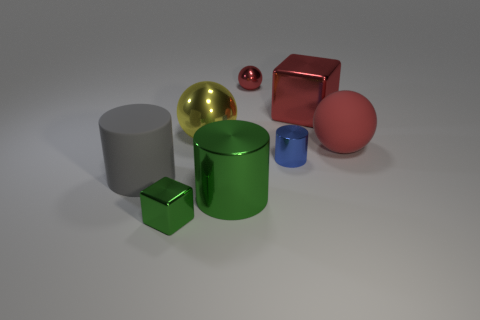There is a small shiny block; does it have the same color as the big cylinder right of the tiny green cube?
Offer a very short reply. Yes. Are there any other things that have the same color as the tiny cube?
Provide a succinct answer. Yes. There is a large metallic object that is the same color as the matte ball; what is its shape?
Make the answer very short. Cube. Is there a ball of the same color as the big block?
Your answer should be compact. Yes. There is a big thing behind the yellow thing; is there a shiny thing that is in front of it?
Ensure brevity in your answer.  Yes. There is another small object that is the same shape as the yellow object; what is its color?
Give a very brief answer. Red. The gray rubber cylinder is what size?
Make the answer very short. Large. Are there fewer rubber objects that are to the right of the red shiny cube than gray rubber things?
Your answer should be very brief. No. Does the large gray object have the same material as the ball in front of the large yellow object?
Make the answer very short. Yes. There is a thing that is left of the tiny shiny object on the left side of the large green metal cylinder; is there a big red metal thing right of it?
Make the answer very short. Yes. 